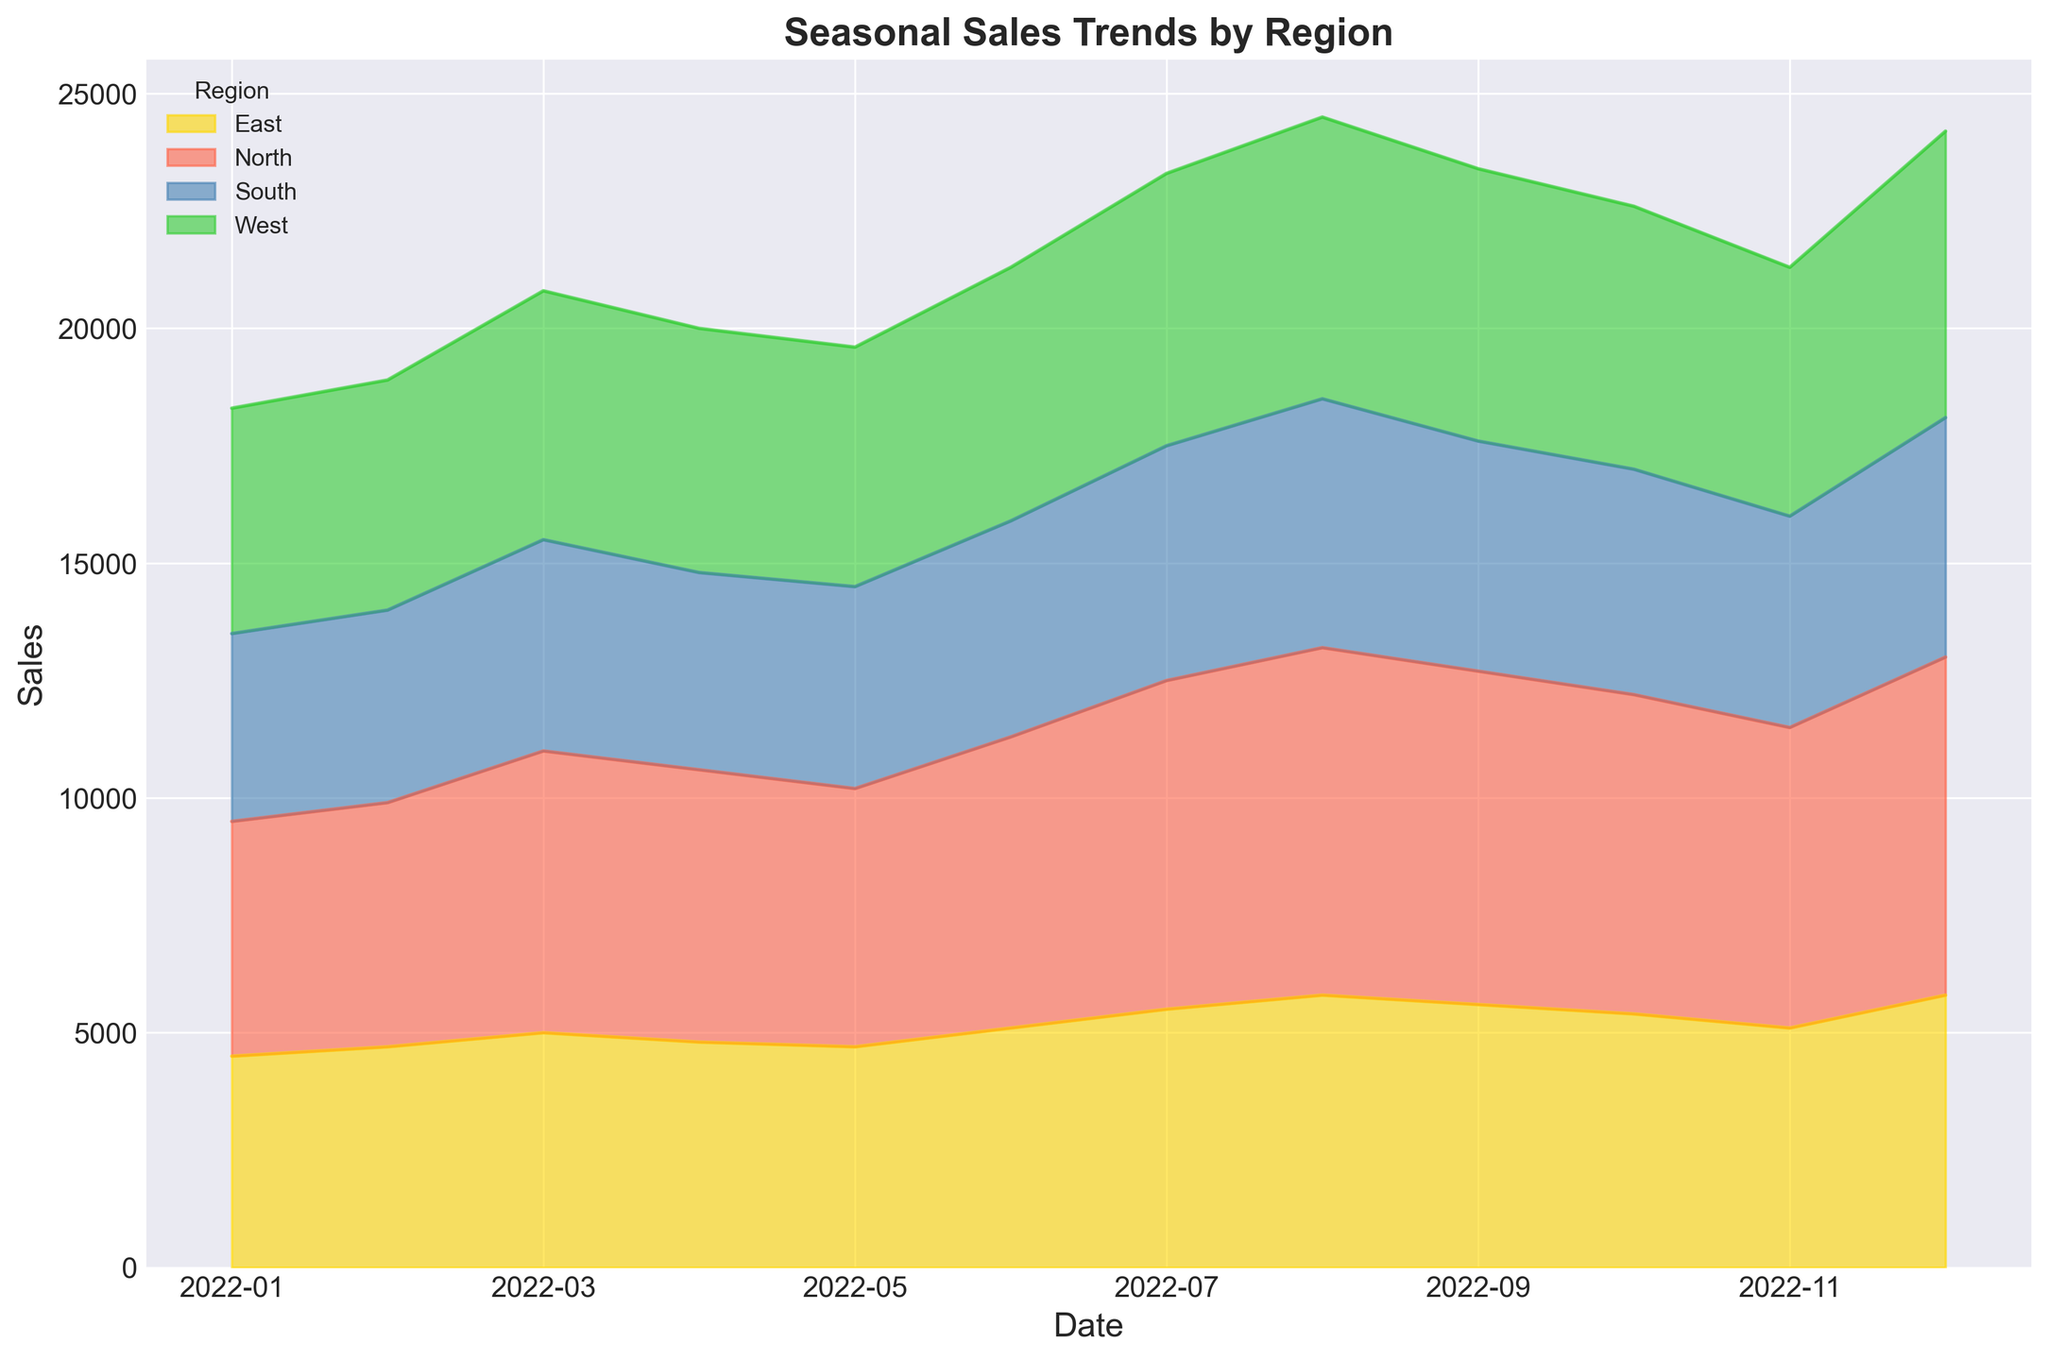what's the total sales for all regions in January? Add up the sales for each region in January: North (5000) + South (4000) + East (4500) + West (4800). 5000 + 4000 + 4500 + 4800 = 18300
Answer: 18300 which region had the highest sales in July? Look for the region with the highest peak in July: North (7000), South (5000), East (5500), West (5800). North has the highest value.
Answer: North how much did the sales for the North region increase from February to March? Subtract February's sales from March's sales for the North region: March (6000) - February (5200). 6000 - 5200 = 800
Answer: 800 which month had the lowest combined sales for all regions? Compare the total sales of all regions for each month: 
- January: 18300
- February: 18900
- March: 20800
- April: 20000
- May: 19600
- June: 21300
- July: 23300
- August: 24500
- September: 23400
- October: 22600
- November: 21300
- December: 24200
January has the lowest combined sales (18300).
Answer: January what was the sales difference between the West and East regions in December? Subtract the sales of East from the sales of West in December: West (6100) - East (5800). 6100 - 5800 = 300
Answer: 300 how did the sales trend for the South region change from May to August? Check the sales for the South region from May to August:
- May: 4300
- June: 4600
- July: 5000
- August: 5300
The trend shows a continuous increase in sales each month.
Answer: Increasing which region had the most consistent sales throughout the year? Look at the sales trends for each region and identify the one with the least fluctuation:
- North: from 5000 to 7200
- South: from 4000 to 5300
- East: from 4500 to 5800
- West: from 4800 to 6100
South region shows the most consistency with the least fluctuation.
Answer: South which regions saw a sales peak in August, and what were their sales figures? Look at the sales figures for each region in August:
- North: 7400
- South: 5300
- East: 5800
- West: 6000
All regions saw their peak sales in August with the listed figures.
Answer: North: 7400, South: 5300, East: 5800, West: 6000 